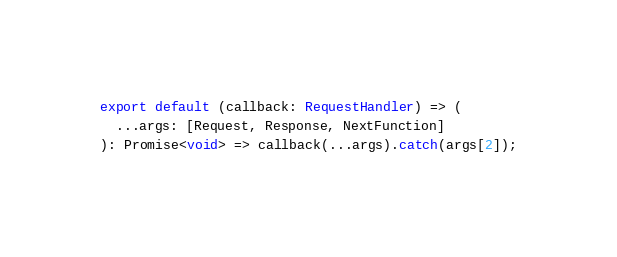<code> <loc_0><loc_0><loc_500><loc_500><_TypeScript_>
export default (callback: RequestHandler) => (
  ...args: [Request, Response, NextFunction]
): Promise<void> => callback(...args).catch(args[2]);
</code> 